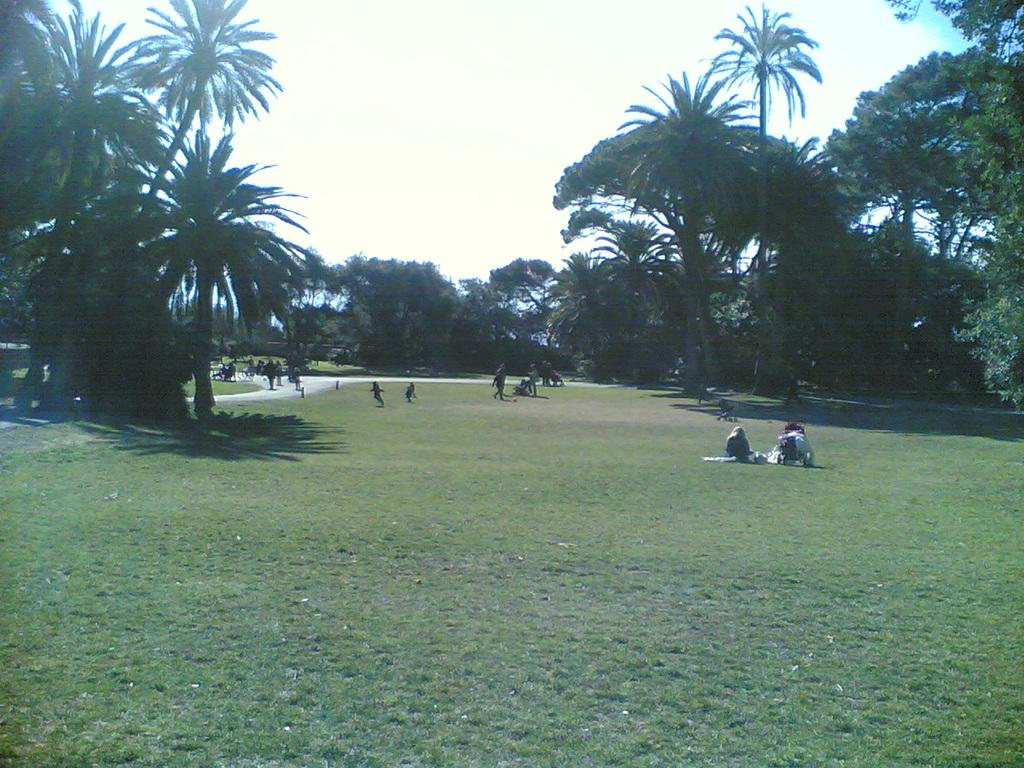How many people are present in the image? There are many people in the image. What are the people wearing? The people are wearing clothes. What are some of the people doing in the image? Some people are sitting, while others are walking. What type of natural environment is visible in the image? There is grass and trees in the image. What is the path used for in the image? The path is likely used for walking or moving around in the area. What is the color of the sky in the image? The sky is white in the image. What type of war is being depicted on the stage in the image? There is no stage or war present in the image; it features people in a natural environment with grass, trees, and a path. What type of property is visible in the image? There is no property visible in the image; it features a natural environment with grass, trees, and a path. 